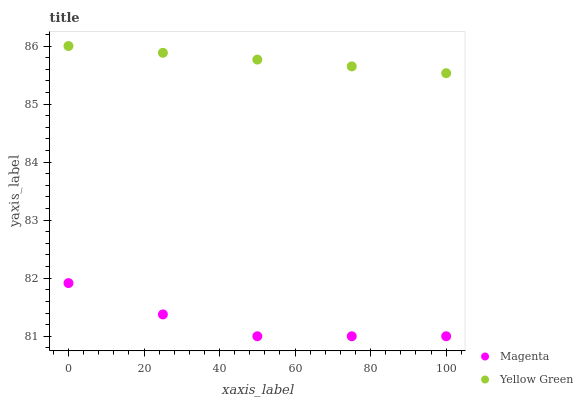Does Magenta have the minimum area under the curve?
Answer yes or no. Yes. Does Yellow Green have the maximum area under the curve?
Answer yes or no. Yes. Does Yellow Green have the minimum area under the curve?
Answer yes or no. No. Is Yellow Green the smoothest?
Answer yes or no. Yes. Is Magenta the roughest?
Answer yes or no. Yes. Is Yellow Green the roughest?
Answer yes or no. No. Does Magenta have the lowest value?
Answer yes or no. Yes. Does Yellow Green have the lowest value?
Answer yes or no. No. Does Yellow Green have the highest value?
Answer yes or no. Yes. Is Magenta less than Yellow Green?
Answer yes or no. Yes. Is Yellow Green greater than Magenta?
Answer yes or no. Yes. Does Magenta intersect Yellow Green?
Answer yes or no. No. 